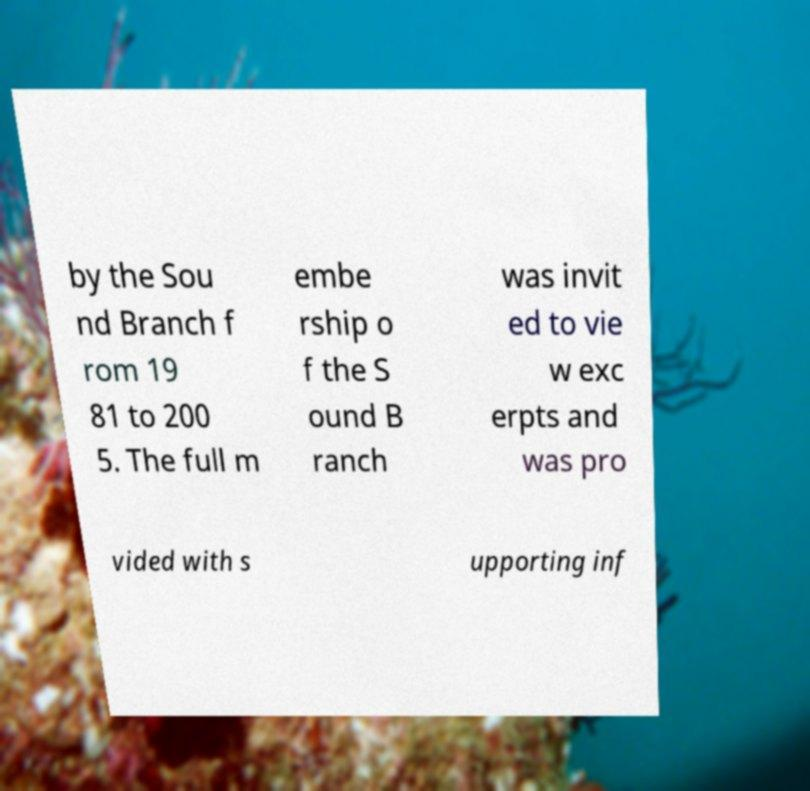Please read and relay the text visible in this image. What does it say? by the Sou nd Branch f rom 19 81 to 200 5. The full m embe rship o f the S ound B ranch was invit ed to vie w exc erpts and was pro vided with s upporting inf 